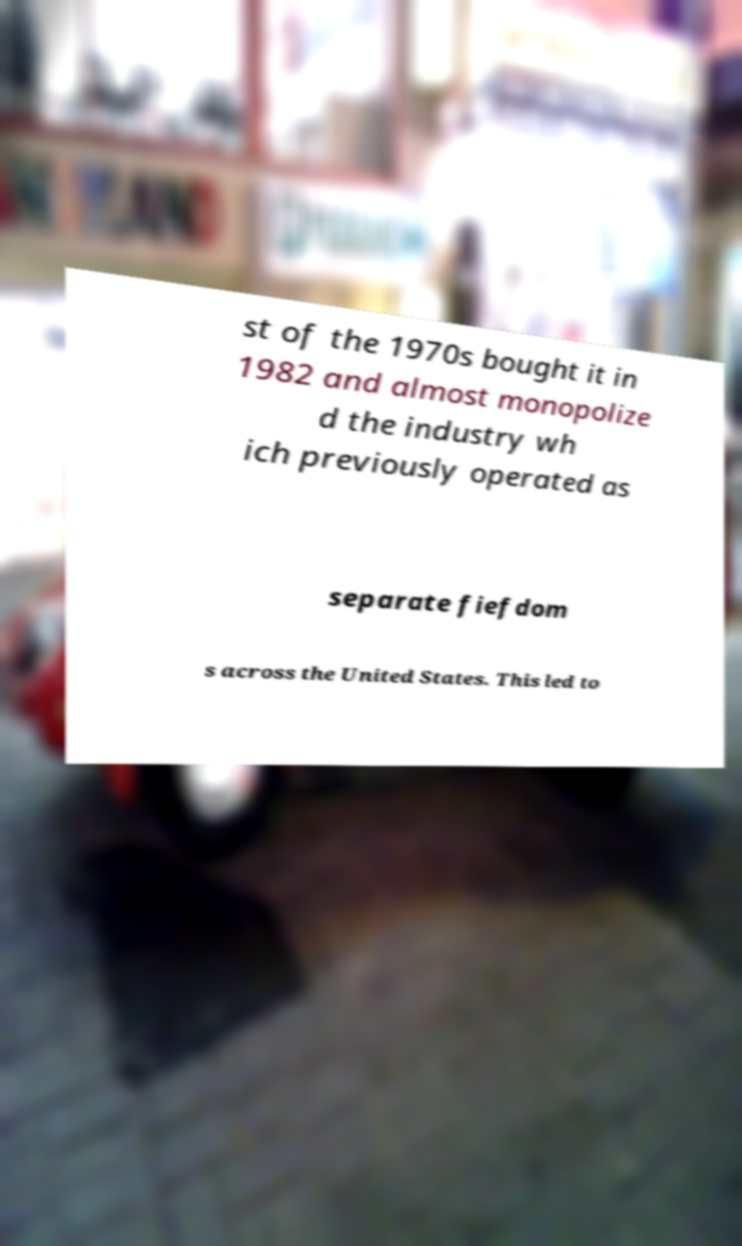There's text embedded in this image that I need extracted. Can you transcribe it verbatim? st of the 1970s bought it in 1982 and almost monopolize d the industry wh ich previously operated as separate fiefdom s across the United States. This led to 